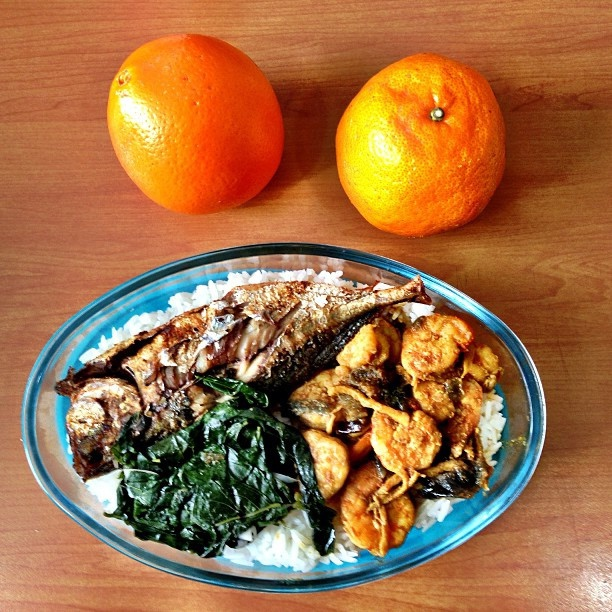Describe the objects in this image and their specific colors. I can see dining table in brown, salmon, maroon, black, and tan tones, bowl in red, black, ivory, maroon, and brown tones, orange in red, orange, and brown tones, and orange in red, orange, gold, and brown tones in this image. 